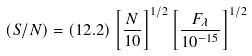Convert formula to latex. <formula><loc_0><loc_0><loc_500><loc_500>( S / N ) = ( 1 2 . 2 ) \left [ \frac { N } { 1 0 } \right ] ^ { 1 / 2 } \left [ \frac { F _ { \lambda } } { 1 0 ^ { - 1 5 } } \right ] ^ { 1 / 2 }</formula> 